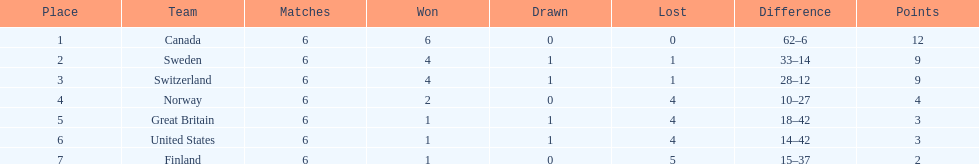Which team positioned after sweden? Switzerland. 